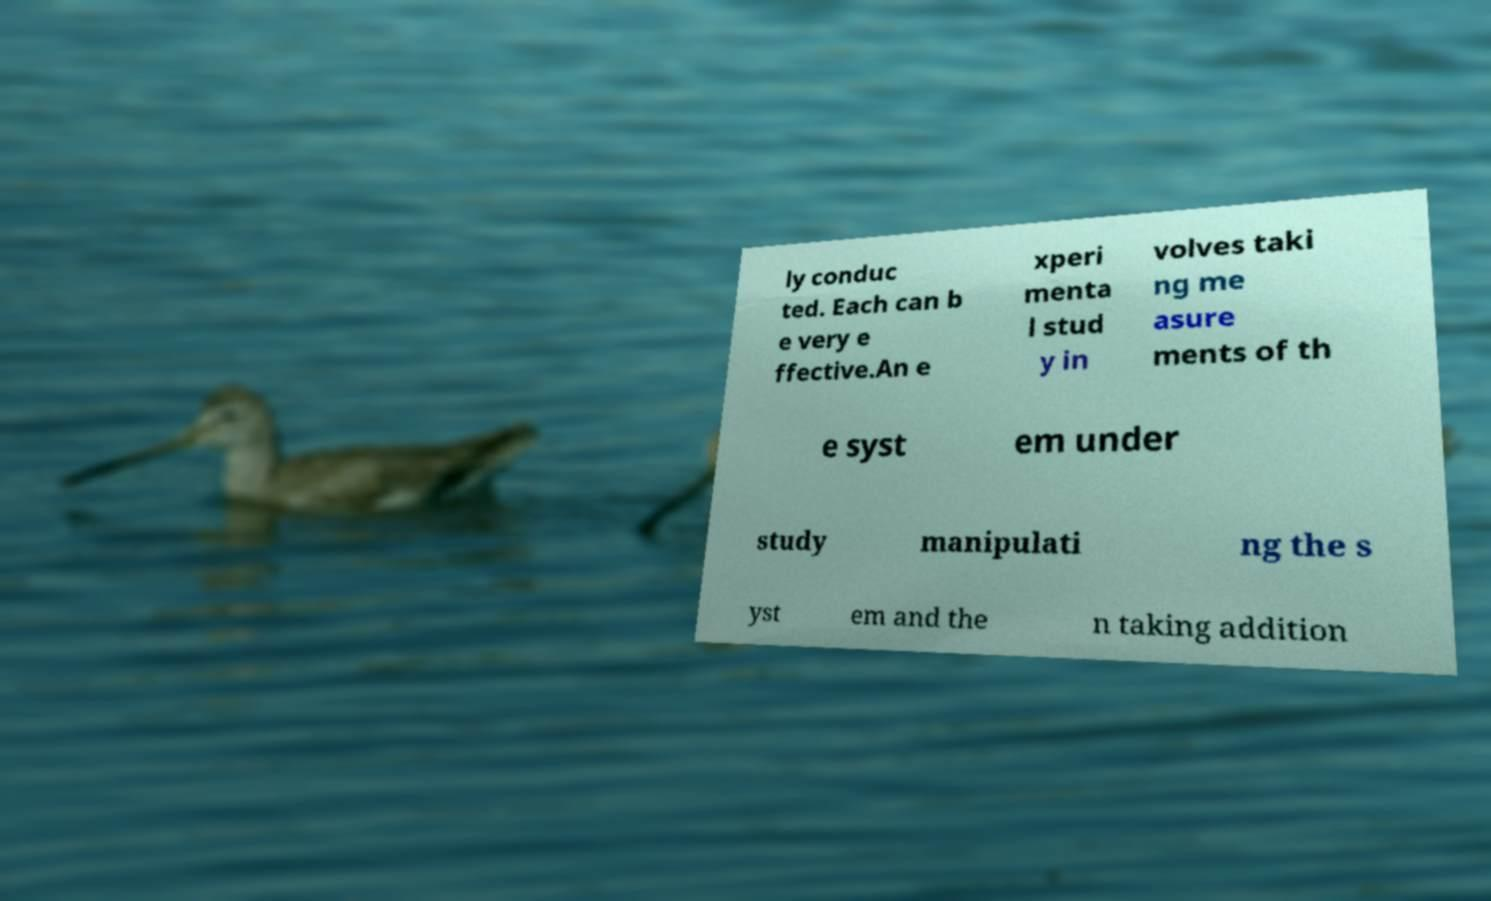Could you assist in decoding the text presented in this image and type it out clearly? ly conduc ted. Each can b e very e ffective.An e xperi menta l stud y in volves taki ng me asure ments of th e syst em under study manipulati ng the s yst em and the n taking addition 